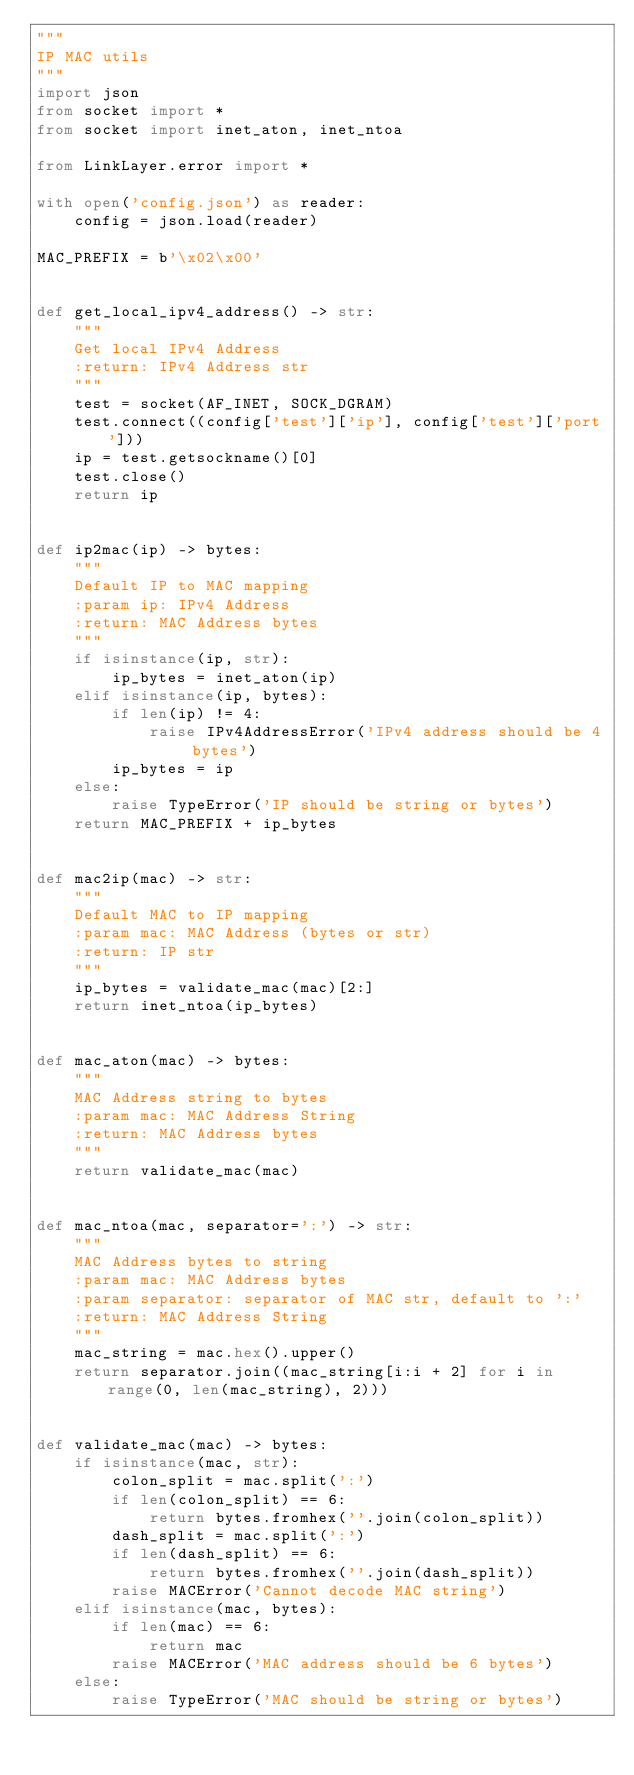<code> <loc_0><loc_0><loc_500><loc_500><_Python_>"""
IP MAC utils
"""
import json
from socket import *
from socket import inet_aton, inet_ntoa

from LinkLayer.error import *

with open('config.json') as reader:
    config = json.load(reader)

MAC_PREFIX = b'\x02\x00'


def get_local_ipv4_address() -> str:
    """
    Get local IPv4 Address
    :return: IPv4 Address str
    """
    test = socket(AF_INET, SOCK_DGRAM)
    test.connect((config['test']['ip'], config['test']['port']))
    ip = test.getsockname()[0]
    test.close()
    return ip


def ip2mac(ip) -> bytes:
    """
    Default IP to MAC mapping
    :param ip: IPv4 Address
    :return: MAC Address bytes
    """
    if isinstance(ip, str):
        ip_bytes = inet_aton(ip)
    elif isinstance(ip, bytes):
        if len(ip) != 4:
            raise IPv4AddressError('IPv4 address should be 4 bytes')
        ip_bytes = ip
    else:
        raise TypeError('IP should be string or bytes')
    return MAC_PREFIX + ip_bytes


def mac2ip(mac) -> str:
    """
    Default MAC to IP mapping
    :param mac: MAC Address (bytes or str)
    :return: IP str
    """
    ip_bytes = validate_mac(mac)[2:]
    return inet_ntoa(ip_bytes)


def mac_aton(mac) -> bytes:
    """
    MAC Address string to bytes
    :param mac: MAC Address String
    :return: MAC Address bytes
    """
    return validate_mac(mac)


def mac_ntoa(mac, separator=':') -> str:
    """
    MAC Address bytes to string
    :param mac: MAC Address bytes
    :param separator: separator of MAC str, default to ':'
    :return: MAC Address String
    """
    mac_string = mac.hex().upper()
    return separator.join((mac_string[i:i + 2] for i in range(0, len(mac_string), 2)))


def validate_mac(mac) -> bytes:
    if isinstance(mac, str):
        colon_split = mac.split(':')
        if len(colon_split) == 6:
            return bytes.fromhex(''.join(colon_split))
        dash_split = mac.split(':')
        if len(dash_split) == 6:
            return bytes.fromhex(''.join(dash_split))
        raise MACError('Cannot decode MAC string')
    elif isinstance(mac, bytes):
        if len(mac) == 6:
            return mac
        raise MACError('MAC address should be 6 bytes')
    else:
        raise TypeError('MAC should be string or bytes')
</code> 